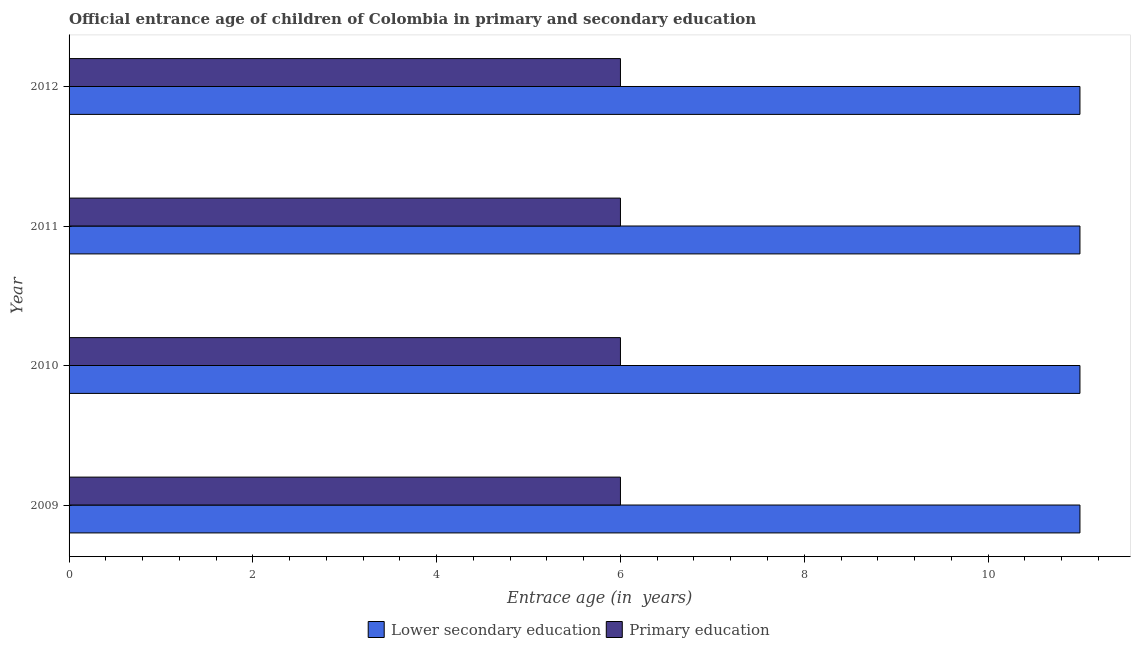Are the number of bars per tick equal to the number of legend labels?
Offer a terse response. Yes. What is the label of the 1st group of bars from the top?
Make the answer very short. 2012. What is the entrance age of chiildren in primary education in 2011?
Make the answer very short. 6. Across all years, what is the maximum entrance age of children in lower secondary education?
Provide a short and direct response. 11. Across all years, what is the minimum entrance age of children in lower secondary education?
Ensure brevity in your answer.  11. What is the total entrance age of chiildren in primary education in the graph?
Give a very brief answer. 24. What is the difference between the entrance age of chiildren in primary education in 2012 and the entrance age of children in lower secondary education in 2011?
Offer a very short reply. -5. What is the average entrance age of chiildren in primary education per year?
Your answer should be compact. 6. In the year 2012, what is the difference between the entrance age of chiildren in primary education and entrance age of children in lower secondary education?
Offer a terse response. -5. What is the difference between the highest and the second highest entrance age of children in lower secondary education?
Your answer should be very brief. 0. In how many years, is the entrance age of children in lower secondary education greater than the average entrance age of children in lower secondary education taken over all years?
Offer a very short reply. 0. What does the 2nd bar from the top in 2011 represents?
Your answer should be compact. Lower secondary education. What does the 1st bar from the bottom in 2009 represents?
Give a very brief answer. Lower secondary education. What is the difference between two consecutive major ticks on the X-axis?
Provide a succinct answer. 2. Are the values on the major ticks of X-axis written in scientific E-notation?
Provide a succinct answer. No. Does the graph contain any zero values?
Provide a succinct answer. No. What is the title of the graph?
Your answer should be very brief. Official entrance age of children of Colombia in primary and secondary education. What is the label or title of the X-axis?
Offer a very short reply. Entrace age (in  years). What is the Entrace age (in  years) in Lower secondary education in 2009?
Your response must be concise. 11. What is the Entrace age (in  years) in Primary education in 2009?
Keep it short and to the point. 6. What is the Entrace age (in  years) in Lower secondary education in 2010?
Your answer should be compact. 11. What is the Entrace age (in  years) of Lower secondary education in 2011?
Your answer should be compact. 11. What is the Entrace age (in  years) in Primary education in 2011?
Ensure brevity in your answer.  6. What is the Entrace age (in  years) of Lower secondary education in 2012?
Provide a succinct answer. 11. Across all years, what is the maximum Entrace age (in  years) of Lower secondary education?
Provide a succinct answer. 11. Across all years, what is the minimum Entrace age (in  years) of Lower secondary education?
Offer a very short reply. 11. What is the total Entrace age (in  years) in Lower secondary education in the graph?
Your response must be concise. 44. What is the difference between the Entrace age (in  years) in Primary education in 2009 and that in 2010?
Offer a terse response. 0. What is the difference between the Entrace age (in  years) in Lower secondary education in 2009 and that in 2011?
Your answer should be very brief. 0. What is the difference between the Entrace age (in  years) of Lower secondary education in 2010 and that in 2012?
Provide a short and direct response. 0. What is the difference between the Entrace age (in  years) of Lower secondary education in 2011 and that in 2012?
Ensure brevity in your answer.  0. What is the difference between the Entrace age (in  years) of Lower secondary education in 2009 and the Entrace age (in  years) of Primary education in 2010?
Offer a very short reply. 5. What is the difference between the Entrace age (in  years) of Lower secondary education in 2009 and the Entrace age (in  years) of Primary education in 2012?
Give a very brief answer. 5. What is the difference between the Entrace age (in  years) of Lower secondary education in 2010 and the Entrace age (in  years) of Primary education in 2011?
Keep it short and to the point. 5. What is the difference between the Entrace age (in  years) in Lower secondary education in 2010 and the Entrace age (in  years) in Primary education in 2012?
Offer a very short reply. 5. What is the difference between the Entrace age (in  years) of Lower secondary education in 2011 and the Entrace age (in  years) of Primary education in 2012?
Your response must be concise. 5. What is the average Entrace age (in  years) of Lower secondary education per year?
Your answer should be very brief. 11. What is the ratio of the Entrace age (in  years) in Lower secondary education in 2009 to that in 2011?
Keep it short and to the point. 1. What is the ratio of the Entrace age (in  years) in Lower secondary education in 2009 to that in 2012?
Make the answer very short. 1. What is the ratio of the Entrace age (in  years) in Lower secondary education in 2010 to that in 2011?
Offer a terse response. 1. What is the ratio of the Entrace age (in  years) of Primary education in 2010 to that in 2011?
Offer a terse response. 1. What is the ratio of the Entrace age (in  years) of Lower secondary education in 2010 to that in 2012?
Your answer should be very brief. 1. What is the ratio of the Entrace age (in  years) of Primary education in 2010 to that in 2012?
Give a very brief answer. 1. What is the difference between the highest and the second highest Entrace age (in  years) of Lower secondary education?
Provide a short and direct response. 0. What is the difference between the highest and the lowest Entrace age (in  years) in Lower secondary education?
Keep it short and to the point. 0. What is the difference between the highest and the lowest Entrace age (in  years) of Primary education?
Your response must be concise. 0. 